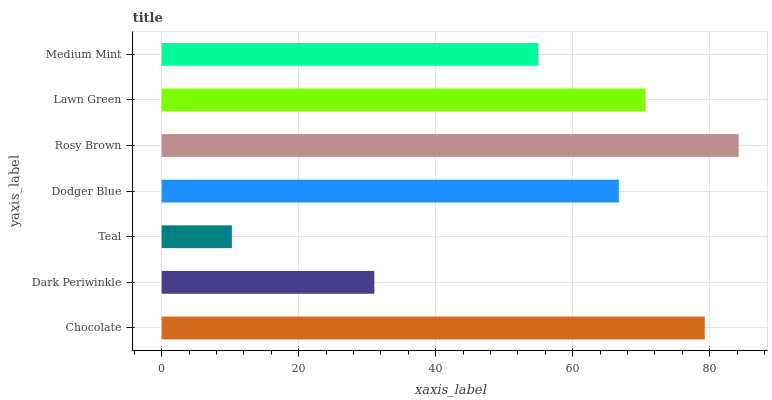Is Teal the minimum?
Answer yes or no. Yes. Is Rosy Brown the maximum?
Answer yes or no. Yes. Is Dark Periwinkle the minimum?
Answer yes or no. No. Is Dark Periwinkle the maximum?
Answer yes or no. No. Is Chocolate greater than Dark Periwinkle?
Answer yes or no. Yes. Is Dark Periwinkle less than Chocolate?
Answer yes or no. Yes. Is Dark Periwinkle greater than Chocolate?
Answer yes or no. No. Is Chocolate less than Dark Periwinkle?
Answer yes or no. No. Is Dodger Blue the high median?
Answer yes or no. Yes. Is Dodger Blue the low median?
Answer yes or no. Yes. Is Dark Periwinkle the high median?
Answer yes or no. No. Is Lawn Green the low median?
Answer yes or no. No. 